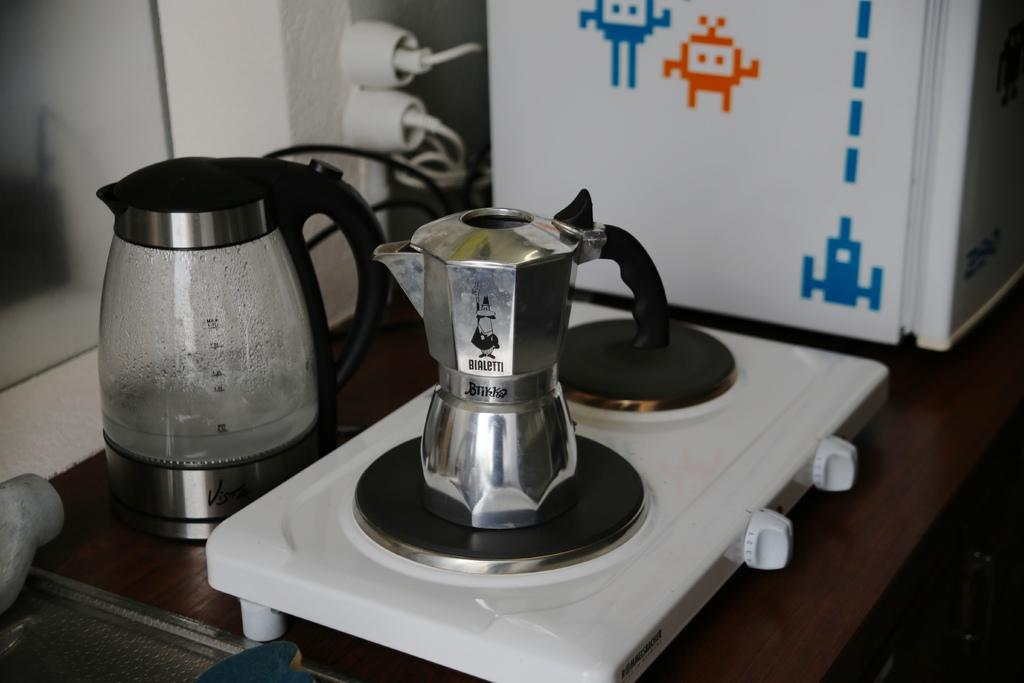Provide a one-sentence caption for the provided image. A coffee pot branded with BIALETTI printed on the surface sitting on a stove burner. 